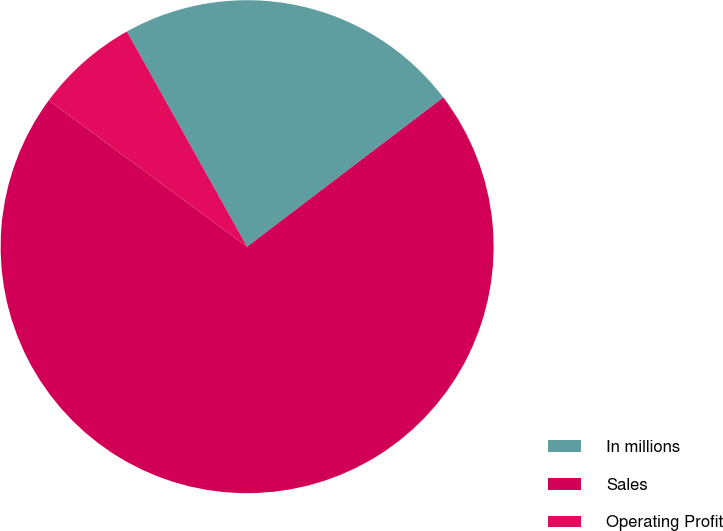<chart> <loc_0><loc_0><loc_500><loc_500><pie_chart><fcel>In millions<fcel>Sales<fcel>Operating Profit<nl><fcel>22.76%<fcel>70.47%<fcel>6.78%<nl></chart> 